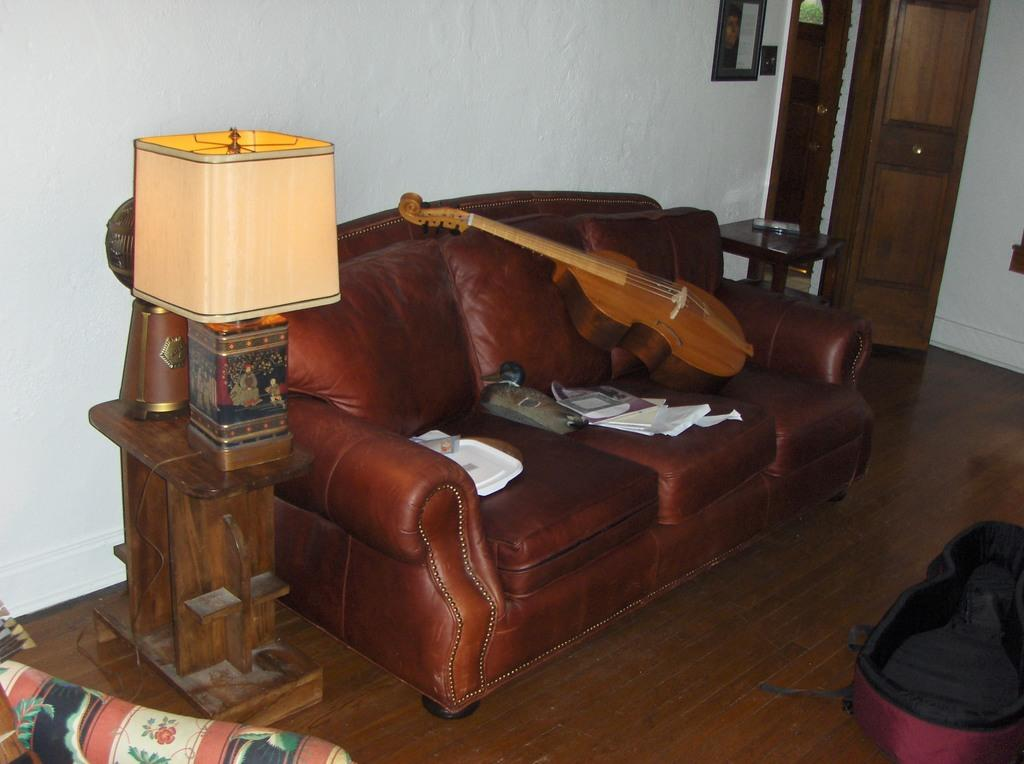What type of furniture is in the image? There is a sofa in the image. What object is placed on the sofa? A guitar is on the sofa. What is another object visible in the image? There is a lamp in the image. What color is the thread used to sew the mind onto the question in the image? There is no thread, mind, or question present in the image. 